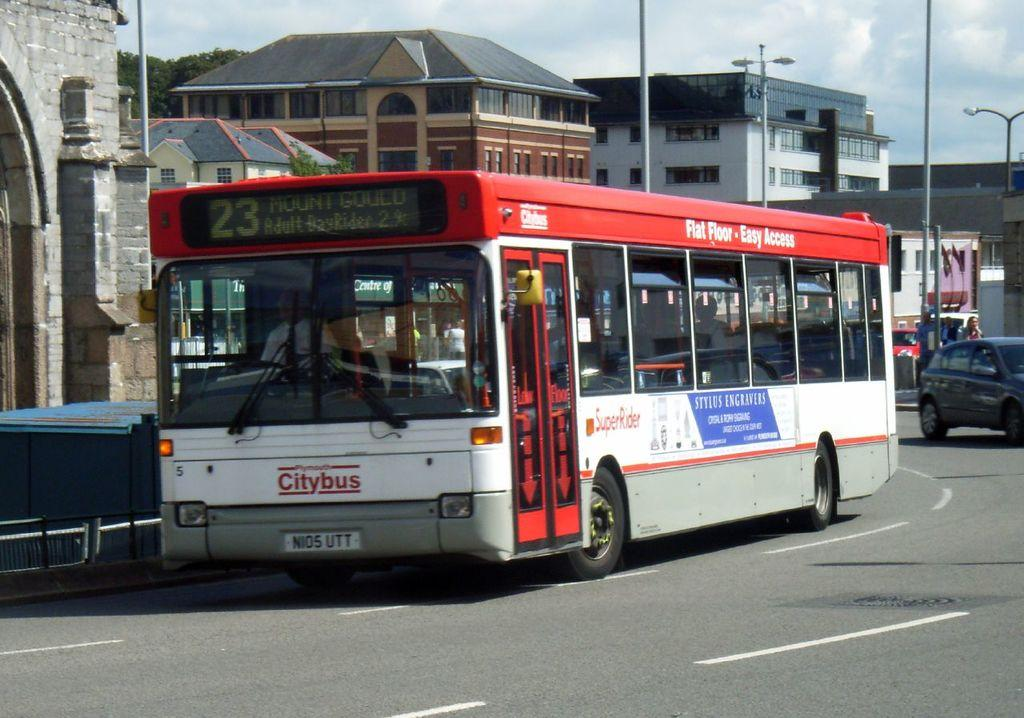What types of vehicles can be seen in the image? There are buses and cars in the image. What is the setting of the vehicles in the image? The vehicles are riding on a road. What can be seen in the background of the image? There are trees, buildings, and electric poles with street lights in the background of the image. Can you see a robin flying over the vehicles in the image? There is no robin present in the image. What is the destination of the journey depicted in the image? The image does not show a specific journey or destination; it simply shows vehicles on a road. 